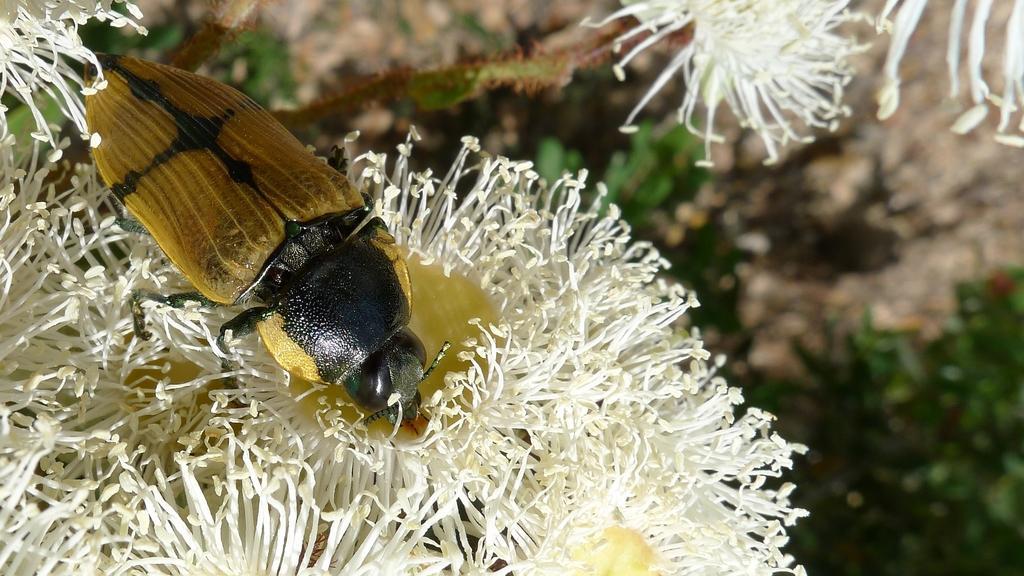In one or two sentences, can you explain what this image depicts? This image consists of a bee sitting on the flower. The flower is in white color. In the background, there are plants. 